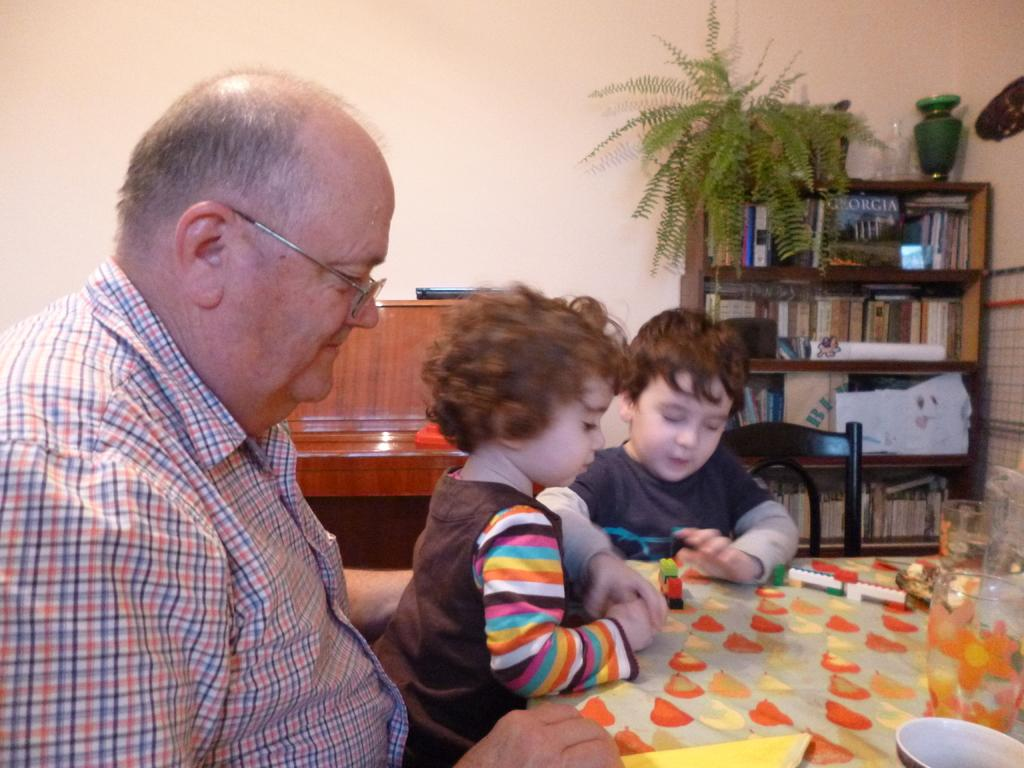Who is present in the image? There is a man and two boys in the image. What can be seen on the man's face? The man is wearing glasses (specs) in the image. What can be seen in the background of the image? There are books and a plant in the background of the image. What type of iron is being used by the man in the image? There is no iron present in the image. The man is wearing glasses, but there is no indication of him using an iron. 